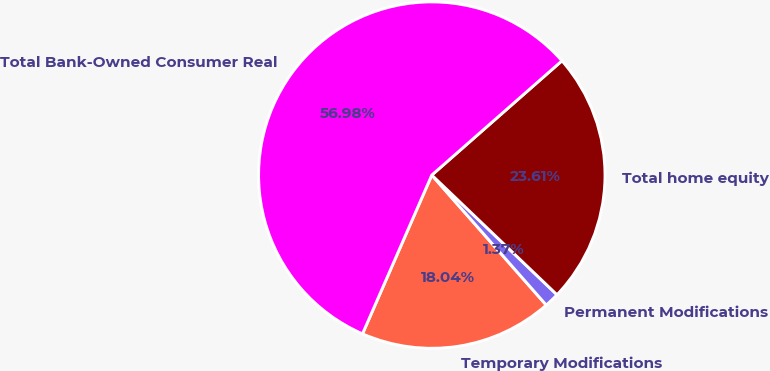Convert chart to OTSL. <chart><loc_0><loc_0><loc_500><loc_500><pie_chart><fcel>Temporary Modifications<fcel>Permanent Modifications<fcel>Total home equity<fcel>Total Bank-Owned Consumer Real<nl><fcel>18.04%<fcel>1.37%<fcel>23.61%<fcel>56.98%<nl></chart> 